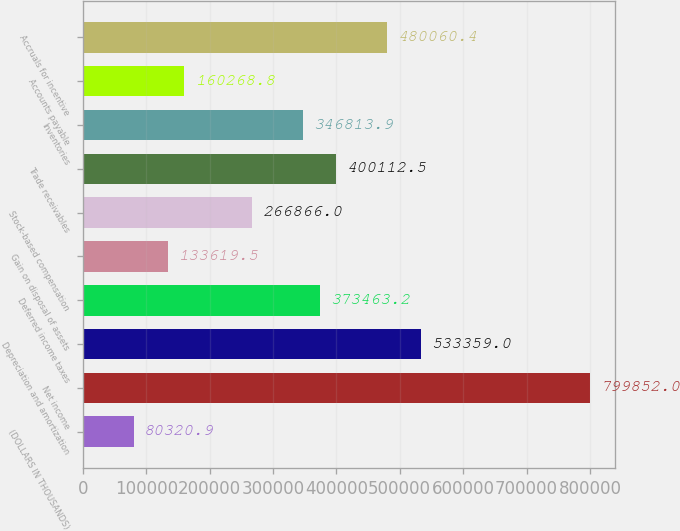<chart> <loc_0><loc_0><loc_500><loc_500><bar_chart><fcel>(DOLLARS IN THOUSANDS)<fcel>Net income<fcel>Depreciation and amortization<fcel>Deferred income taxes<fcel>Gain on disposal of assets<fcel>Stock-based compensation<fcel>Trade receivables<fcel>Inventories<fcel>Accounts payable<fcel>Accruals for incentive<nl><fcel>80320.9<fcel>799852<fcel>533359<fcel>373463<fcel>133620<fcel>266866<fcel>400112<fcel>346814<fcel>160269<fcel>480060<nl></chart> 